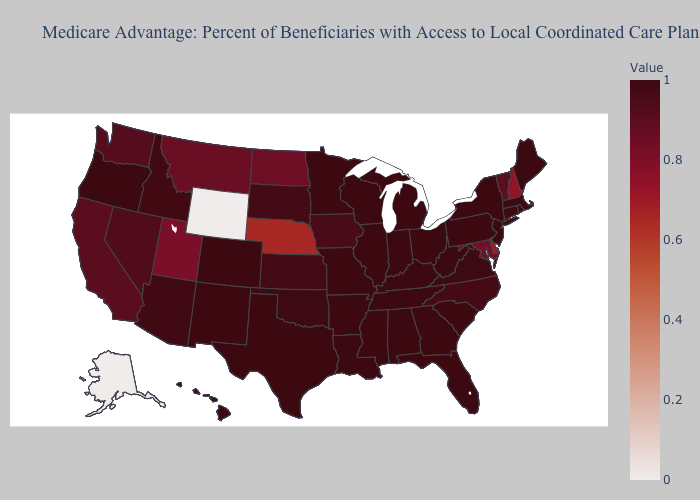Does the map have missing data?
Keep it brief. No. Is the legend a continuous bar?
Give a very brief answer. Yes. Among the states that border Oklahoma , which have the highest value?
Be succinct. Missouri, New Mexico, Texas, Arkansas. Which states hav the highest value in the South?
Answer briefly. Florida, Georgia, Kentucky, Louisiana, Mississippi, South Carolina, Tennessee, Texas, West Virginia, Alabama, Arkansas. Is the legend a continuous bar?
Short answer required. Yes. 